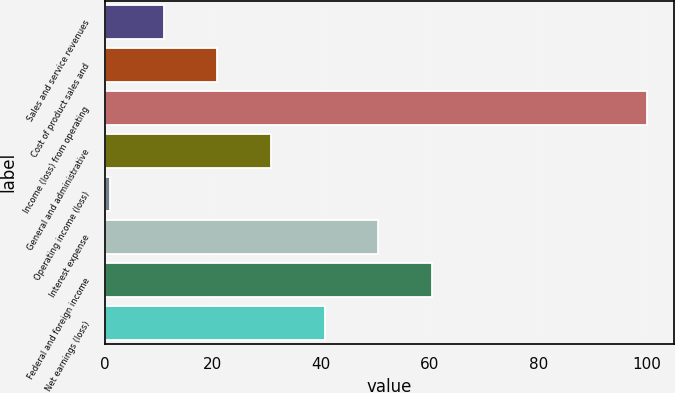Convert chart to OTSL. <chart><loc_0><loc_0><loc_500><loc_500><bar_chart><fcel>Sales and service revenues<fcel>Cost of product sales and<fcel>Income (loss) from operating<fcel>General and administrative<fcel>Operating income (loss)<fcel>Interest expense<fcel>Federal and foreign income<fcel>Net earnings (loss)<nl><fcel>10.9<fcel>20.8<fcel>100<fcel>30.7<fcel>1<fcel>50.5<fcel>60.4<fcel>40.6<nl></chart> 